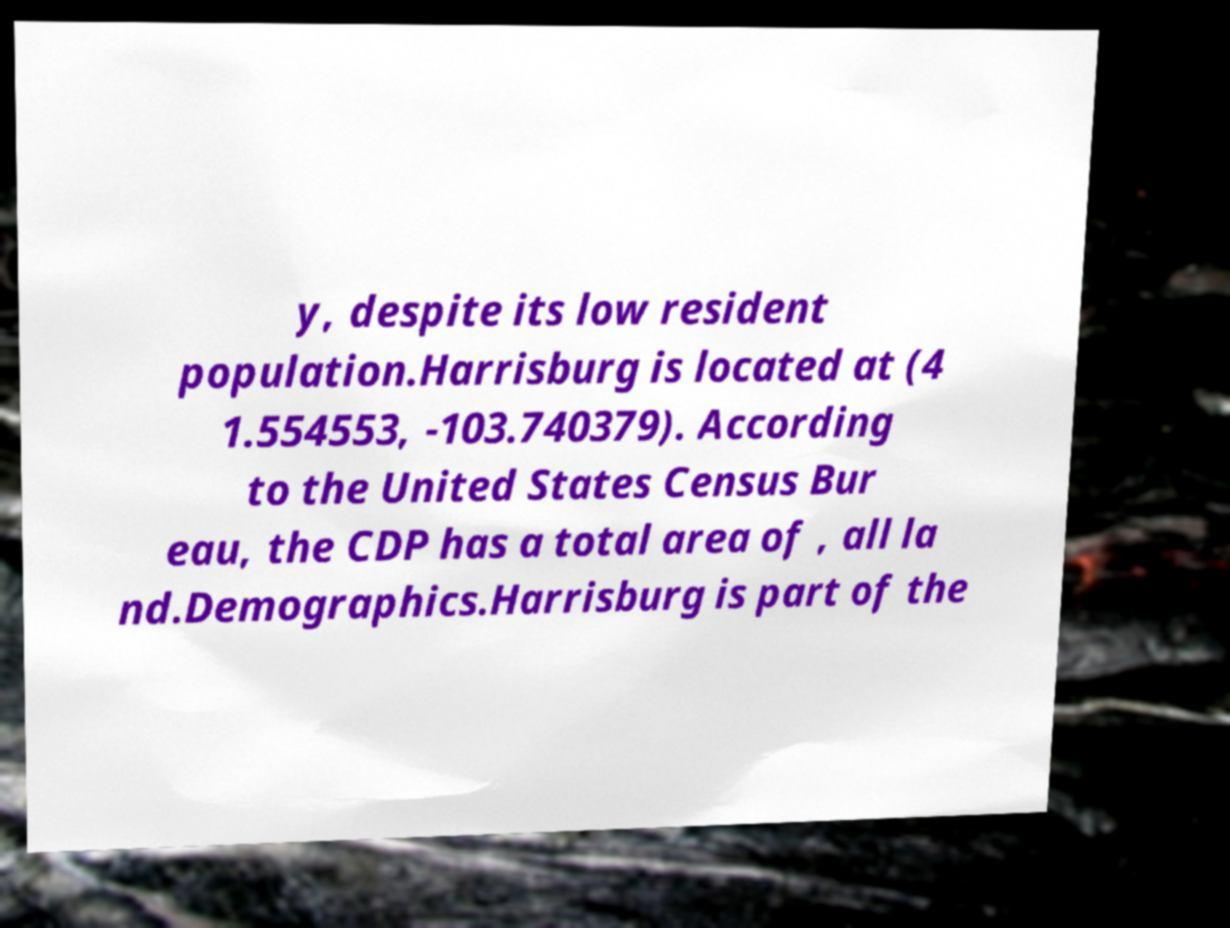Please read and relay the text visible in this image. What does it say? y, despite its low resident population.Harrisburg is located at (4 1.554553, -103.740379). According to the United States Census Bur eau, the CDP has a total area of , all la nd.Demographics.Harrisburg is part of the 